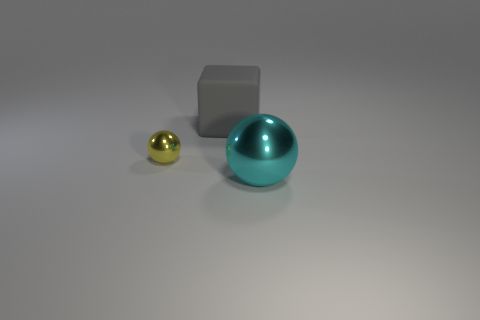Add 1 tiny red metal spheres. How many objects exist? 4 Subtract all balls. How many objects are left? 1 Add 2 large blue objects. How many large blue objects exist? 2 Subtract 1 gray cubes. How many objects are left? 2 Subtract all tiny cyan metallic things. Subtract all large metallic balls. How many objects are left? 2 Add 1 gray cubes. How many gray cubes are left? 2 